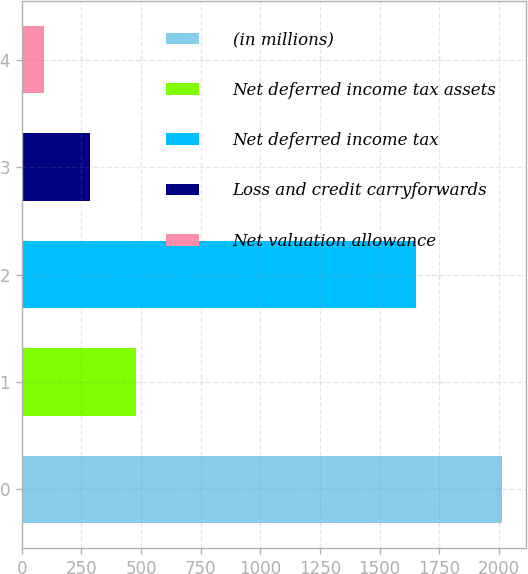<chart> <loc_0><loc_0><loc_500><loc_500><bar_chart><fcel>(in millions)<fcel>Net deferred income tax assets<fcel>Net deferred income tax<fcel>Loss and credit carryforwards<fcel>Net valuation allowance<nl><fcel>2014<fcel>478<fcel>1653<fcel>286<fcel>94<nl></chart> 